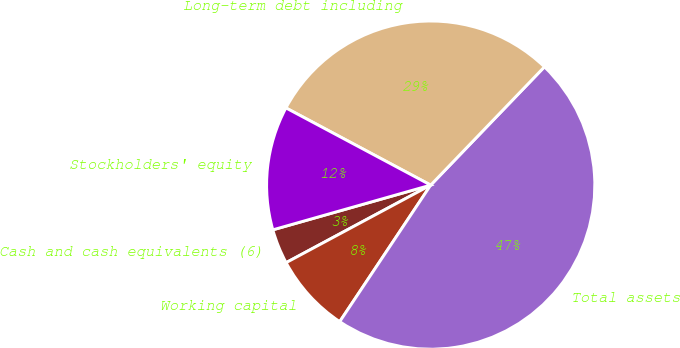Convert chart to OTSL. <chart><loc_0><loc_0><loc_500><loc_500><pie_chart><fcel>Cash and cash equivalents (6)<fcel>Working capital<fcel>Total assets<fcel>Long-term debt including<fcel>Stockholders' equity<nl><fcel>3.44%<fcel>7.81%<fcel>47.16%<fcel>29.39%<fcel>12.19%<nl></chart> 